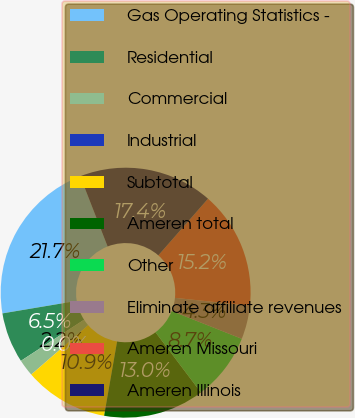Convert chart. <chart><loc_0><loc_0><loc_500><loc_500><pie_chart><fcel>Gas Operating Statistics -<fcel>Residential<fcel>Commercial<fcel>Industrial<fcel>Subtotal<fcel>Ameren total<fcel>Other<fcel>Eliminate affiliate revenues<fcel>Ameren Missouri<fcel>Ameren Illinois<nl><fcel>21.73%<fcel>6.53%<fcel>2.18%<fcel>0.01%<fcel>10.87%<fcel>13.04%<fcel>8.7%<fcel>4.35%<fcel>15.21%<fcel>17.38%<nl></chart> 